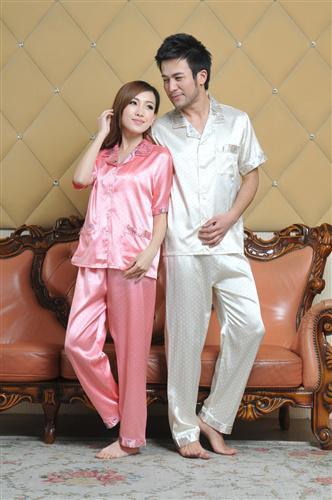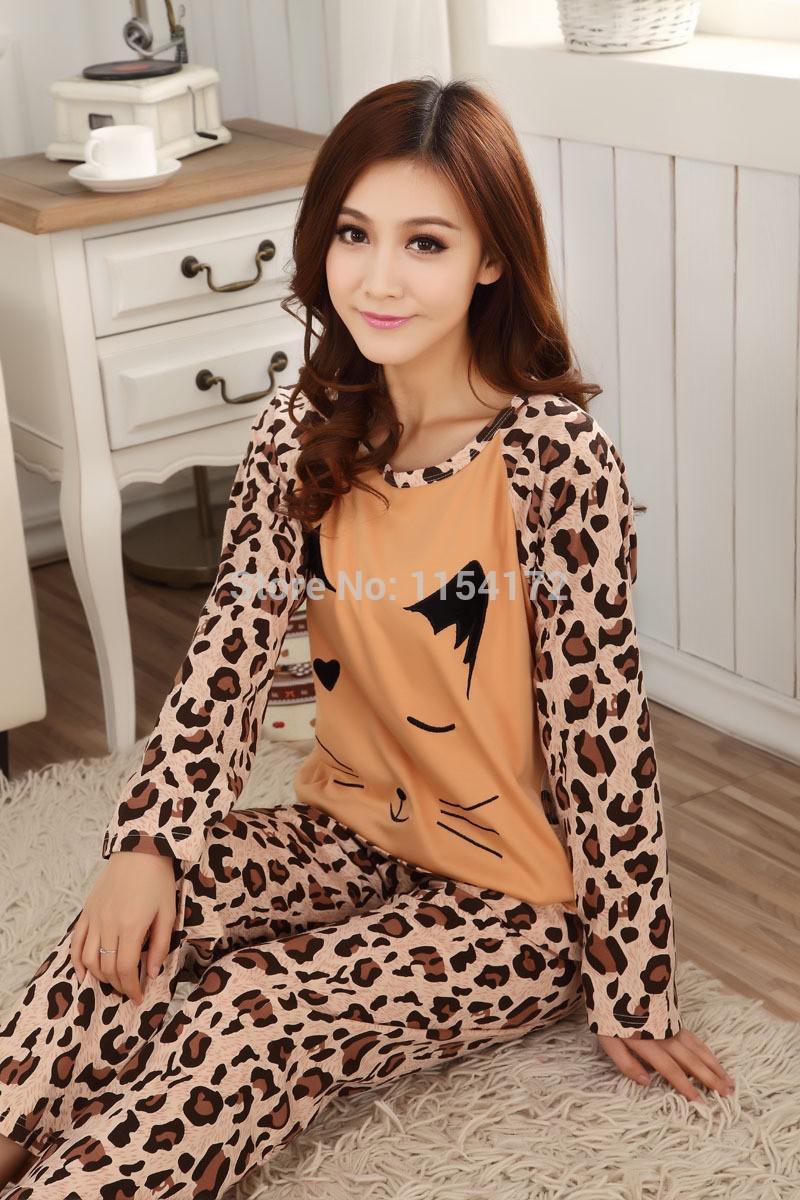The first image is the image on the left, the second image is the image on the right. Analyze the images presented: Is the assertion "A man and woman in pajamas pose near a sofa in one of the images." valid? Answer yes or no. Yes. The first image is the image on the left, the second image is the image on the right. Given the left and right images, does the statement "An image shows a man to the right of a woman, and both are modeling shiny loungewear." hold true? Answer yes or no. Yes. 